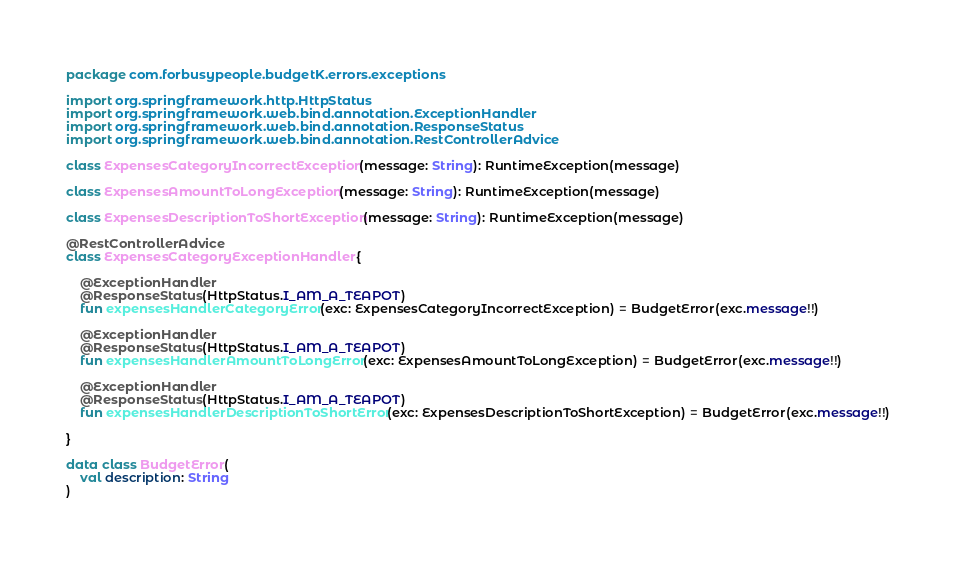Convert code to text. <code><loc_0><loc_0><loc_500><loc_500><_Kotlin_>package com.forbusypeople.budgetK.errors.exceptions

import org.springframework.http.HttpStatus
import org.springframework.web.bind.annotation.ExceptionHandler
import org.springframework.web.bind.annotation.ResponseStatus
import org.springframework.web.bind.annotation.RestControllerAdvice

class ExpensesCategoryIncorrectException(message: String): RuntimeException(message)

class ExpensesAmountToLongException(message: String): RuntimeException(message)

class ExpensesDescriptionToShortException(message: String): RuntimeException(message)

@RestControllerAdvice
class ExpensesCategoryExceptionHandler {

    @ExceptionHandler
    @ResponseStatus(HttpStatus.I_AM_A_TEAPOT)
    fun expensesHandlerCategoryError(exc: ExpensesCategoryIncorrectException) = BudgetError(exc.message!!)

    @ExceptionHandler
    @ResponseStatus(HttpStatus.I_AM_A_TEAPOT)
    fun expensesHandlerAmountToLongError(exc: ExpensesAmountToLongException) = BudgetError(exc.message!!)

    @ExceptionHandler
    @ResponseStatus(HttpStatus.I_AM_A_TEAPOT)
    fun expensesHandlerDescriptionToShortError(exc: ExpensesDescriptionToShortException) = BudgetError(exc.message!!)

}

data class BudgetError(
    val description: String
)</code> 